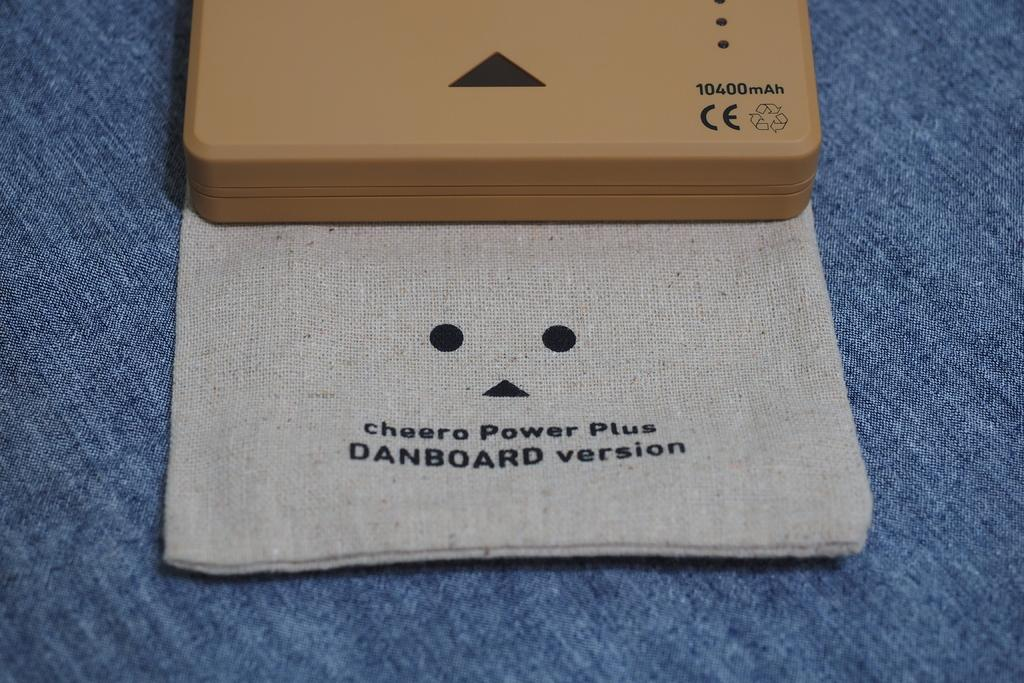<image>
Describe the image concisely. A plastic box sits on a cloth bag for a Cheero Power Plus. 